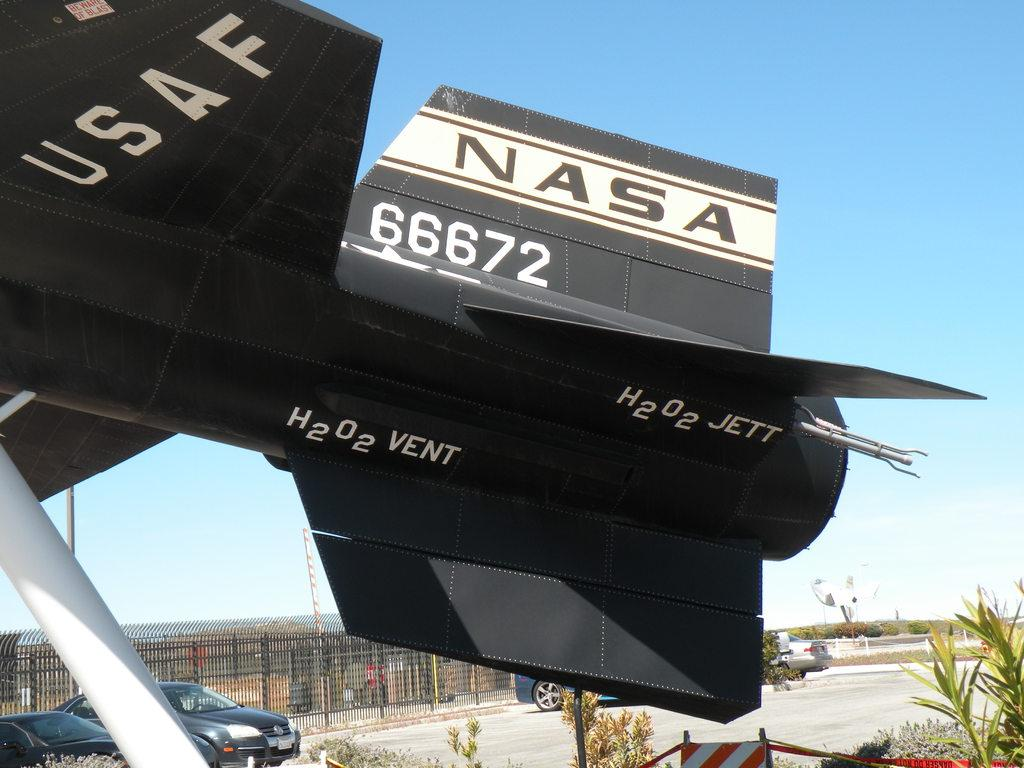<image>
Render a clear and concise summary of the photo. a plane that says 'nasa 66672' on the back end of it 